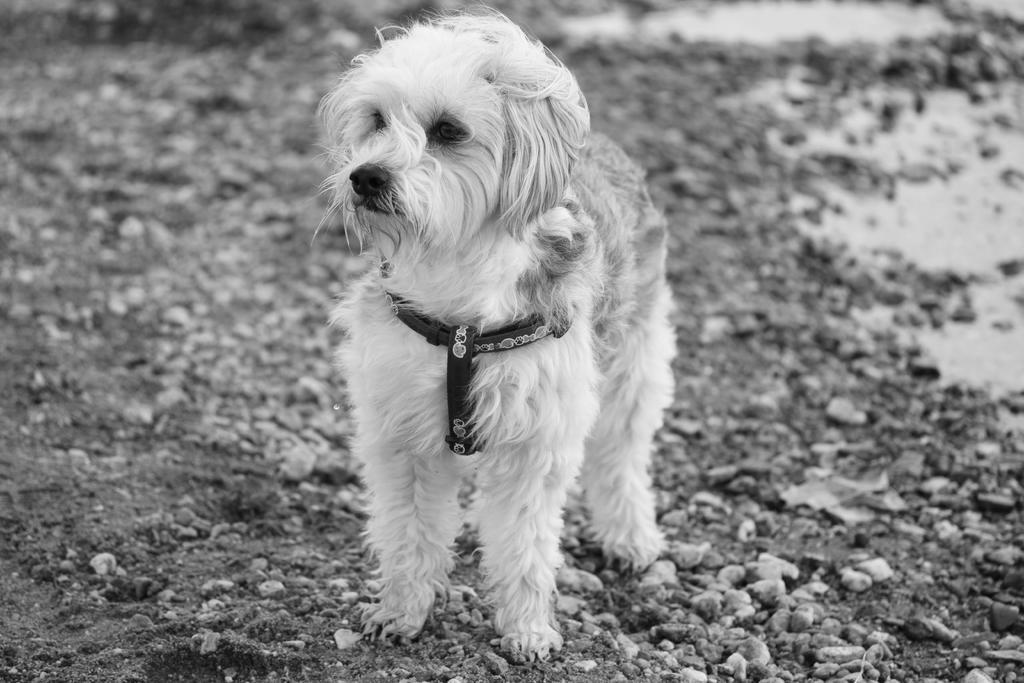Describe this image in one or two sentences. In this picture I can see a dog is standing on the ground. The dog is wearing a dog collar belt. In the background I can see stones on the ground. This picture is black and white in color. 